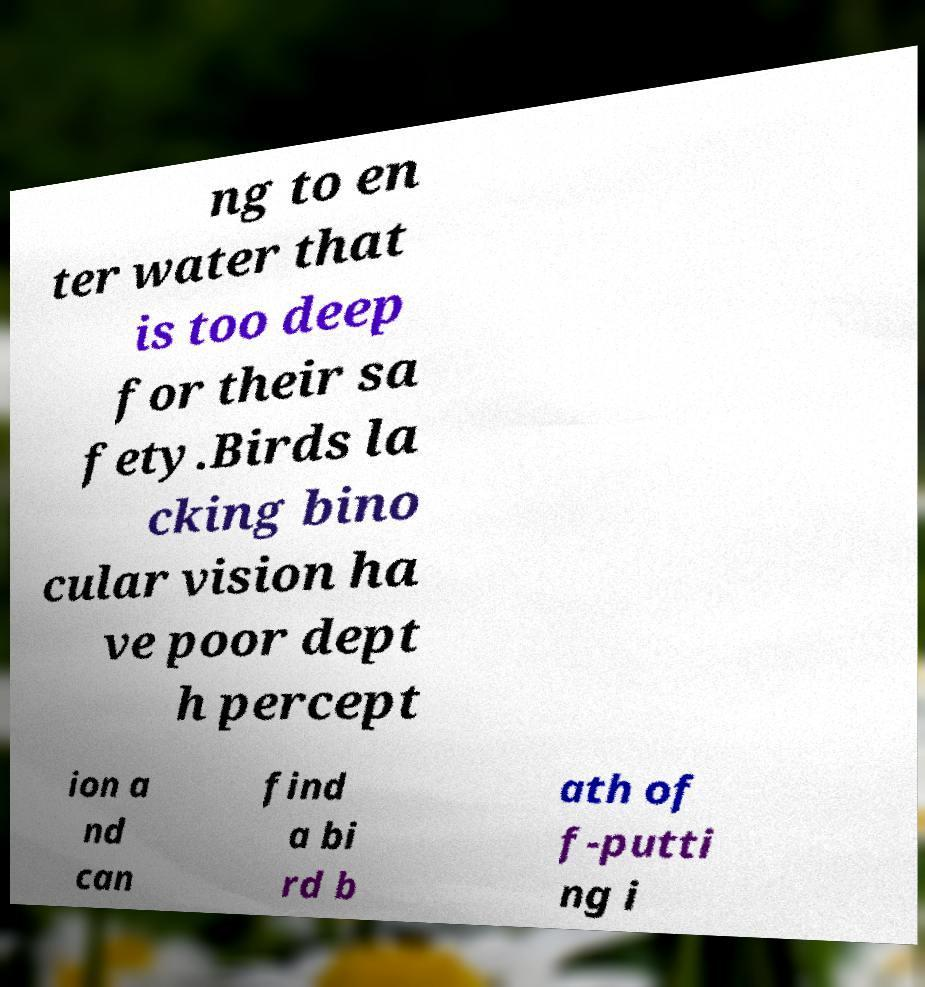Could you extract and type out the text from this image? ng to en ter water that is too deep for their sa fety.Birds la cking bino cular vision ha ve poor dept h percept ion a nd can find a bi rd b ath of f-putti ng i 